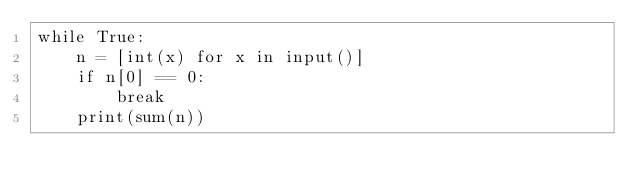<code> <loc_0><loc_0><loc_500><loc_500><_Python_>while True:
    n = [int(x) for x in input()]
    if n[0] == 0:
        break
    print(sum(n))</code> 